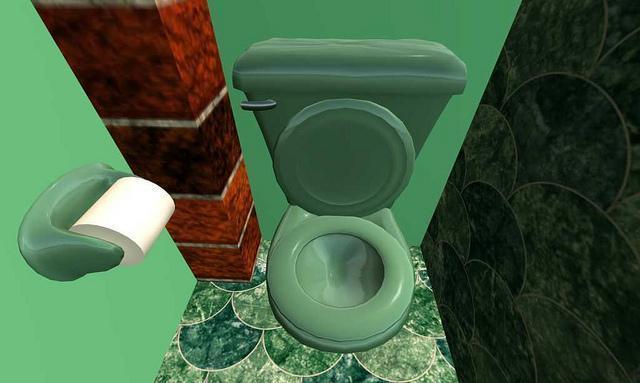How many toilets are there?
Give a very brief answer. 1. 